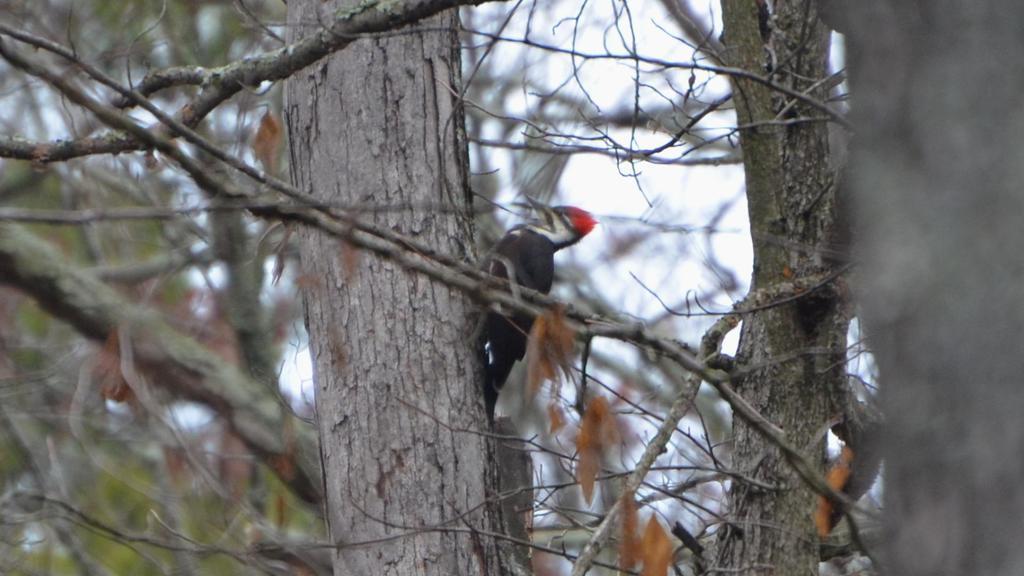In one or two sentences, can you explain what this image depicts? In this image I can see a bird which is black, white and red in color is on the tree trunk which is ash in color. In the background I can see few trees and the sky. 